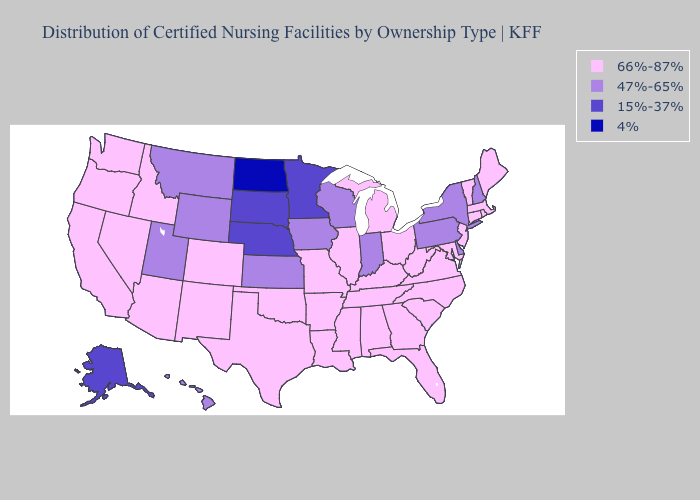Among the states that border Maryland , which have the highest value?
Be succinct. Virginia, West Virginia. Does Louisiana have the highest value in the USA?
Answer briefly. Yes. What is the lowest value in the South?
Short answer required. 47%-65%. What is the value of Wisconsin?
Answer briefly. 47%-65%. Does the map have missing data?
Answer briefly. No. What is the highest value in the West ?
Concise answer only. 66%-87%. What is the highest value in states that border Kansas?
Short answer required. 66%-87%. What is the value of Washington?
Answer briefly. 66%-87%. Does South Dakota have a higher value than North Dakota?
Keep it brief. Yes. What is the value of New Mexico?
Quick response, please. 66%-87%. Among the states that border Vermont , which have the highest value?
Short answer required. Massachusetts. Name the states that have a value in the range 66%-87%?
Be succinct. Alabama, Arizona, Arkansas, California, Colorado, Connecticut, Florida, Georgia, Idaho, Illinois, Kentucky, Louisiana, Maine, Maryland, Massachusetts, Michigan, Mississippi, Missouri, Nevada, New Jersey, New Mexico, North Carolina, Ohio, Oklahoma, Oregon, Rhode Island, South Carolina, Tennessee, Texas, Vermont, Virginia, Washington, West Virginia. What is the highest value in the South ?
Write a very short answer. 66%-87%. Does Oklahoma have a lower value than Wyoming?
Answer briefly. No. Which states hav the highest value in the South?
Answer briefly. Alabama, Arkansas, Florida, Georgia, Kentucky, Louisiana, Maryland, Mississippi, North Carolina, Oklahoma, South Carolina, Tennessee, Texas, Virginia, West Virginia. 